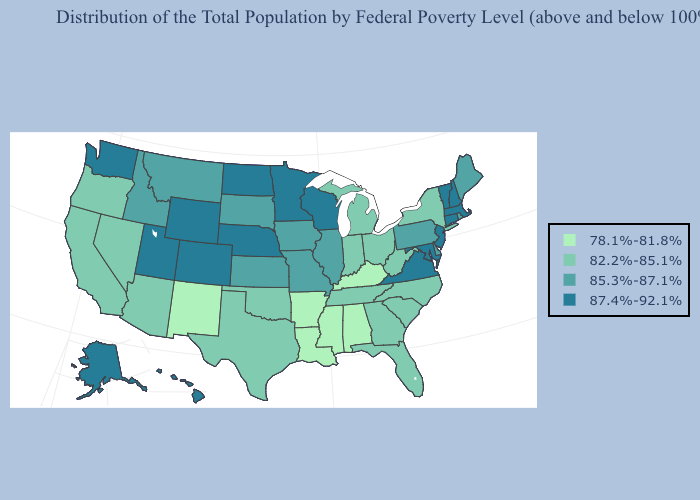Which states have the highest value in the USA?
Give a very brief answer. Alaska, Colorado, Connecticut, Hawaii, Maryland, Massachusetts, Minnesota, Nebraska, New Hampshire, New Jersey, North Dakota, Utah, Vermont, Virginia, Washington, Wisconsin, Wyoming. What is the value of South Dakota?
Keep it brief. 85.3%-87.1%. Name the states that have a value in the range 78.1%-81.8%?
Quick response, please. Alabama, Arkansas, Kentucky, Louisiana, Mississippi, New Mexico. Name the states that have a value in the range 87.4%-92.1%?
Write a very short answer. Alaska, Colorado, Connecticut, Hawaii, Maryland, Massachusetts, Minnesota, Nebraska, New Hampshire, New Jersey, North Dakota, Utah, Vermont, Virginia, Washington, Wisconsin, Wyoming. Does North Carolina have the highest value in the USA?
Concise answer only. No. Name the states that have a value in the range 87.4%-92.1%?
Keep it brief. Alaska, Colorado, Connecticut, Hawaii, Maryland, Massachusetts, Minnesota, Nebraska, New Hampshire, New Jersey, North Dakota, Utah, Vermont, Virginia, Washington, Wisconsin, Wyoming. What is the lowest value in the USA?
Concise answer only. 78.1%-81.8%. Name the states that have a value in the range 78.1%-81.8%?
Be succinct. Alabama, Arkansas, Kentucky, Louisiana, Mississippi, New Mexico. Does New Mexico have the lowest value in the USA?
Concise answer only. Yes. What is the highest value in states that border New Mexico?
Keep it brief. 87.4%-92.1%. Does Arizona have the highest value in the West?
Quick response, please. No. What is the value of Alabama?
Give a very brief answer. 78.1%-81.8%. What is the value of South Carolina?
Quick response, please. 82.2%-85.1%. Name the states that have a value in the range 78.1%-81.8%?
Be succinct. Alabama, Arkansas, Kentucky, Louisiana, Mississippi, New Mexico. What is the value of Rhode Island?
Keep it brief. 85.3%-87.1%. 